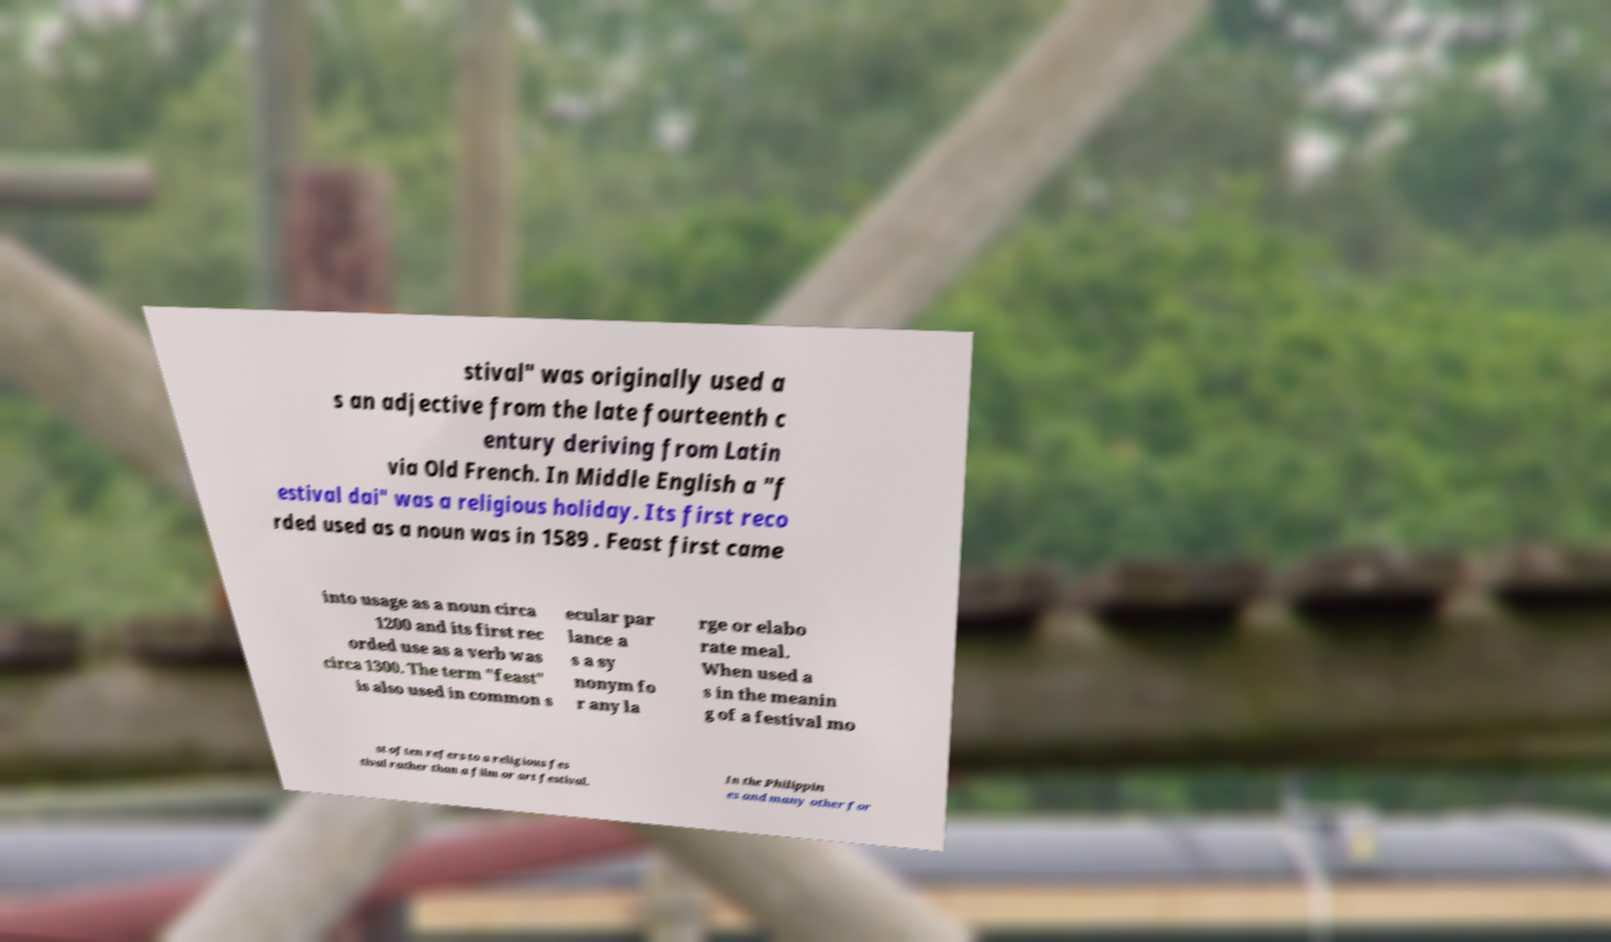Could you assist in decoding the text presented in this image and type it out clearly? stival" was originally used a s an adjective from the late fourteenth c entury deriving from Latin via Old French. In Middle English a "f estival dai" was a religious holiday. Its first reco rded used as a noun was in 1589 . Feast first came into usage as a noun circa 1200 and its first rec orded use as a verb was circa 1300. The term "feast" is also used in common s ecular par lance a s a sy nonym fo r any la rge or elabo rate meal. When used a s in the meanin g of a festival mo st often refers to a religious fes tival rather than a film or art festival. In the Philippin es and many other for 